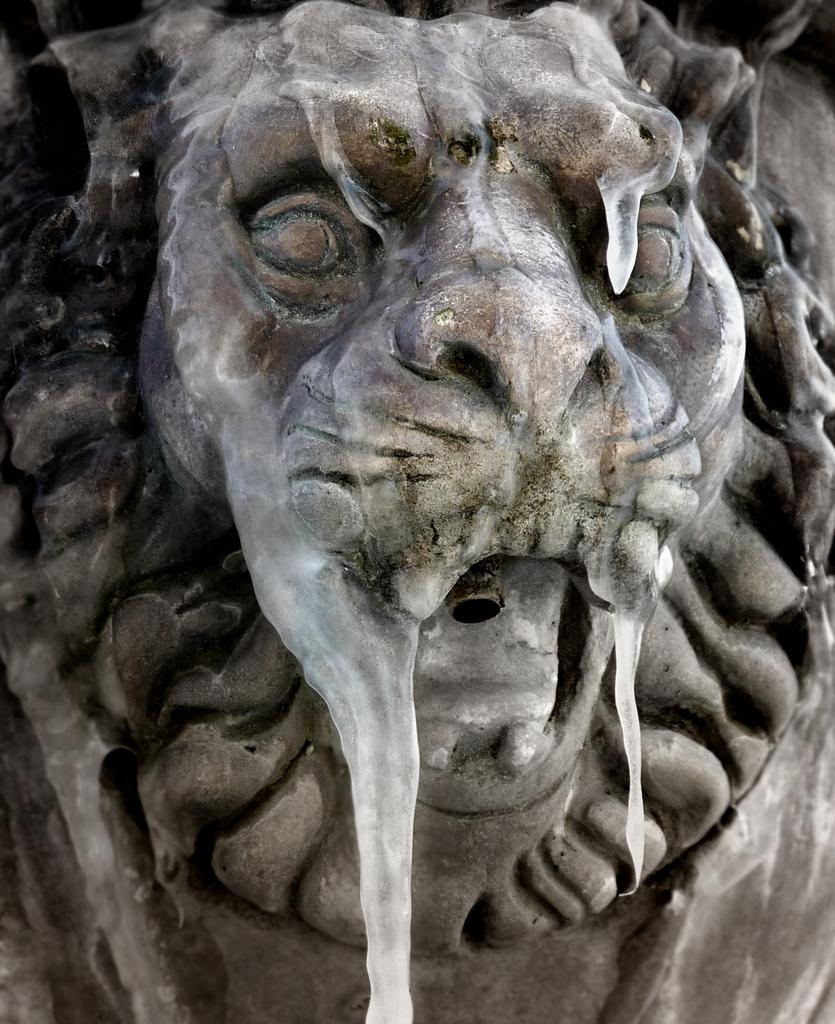What is the main subject of the image? There is a statue in the image. What is the statue of? The statue is of a lion. Where is the statue located in the image? The statue is in the middle of the image. What type of attack is the monkey performing on the statue in the image? There is no monkey present in the image, and therefore no attack can be observed. 